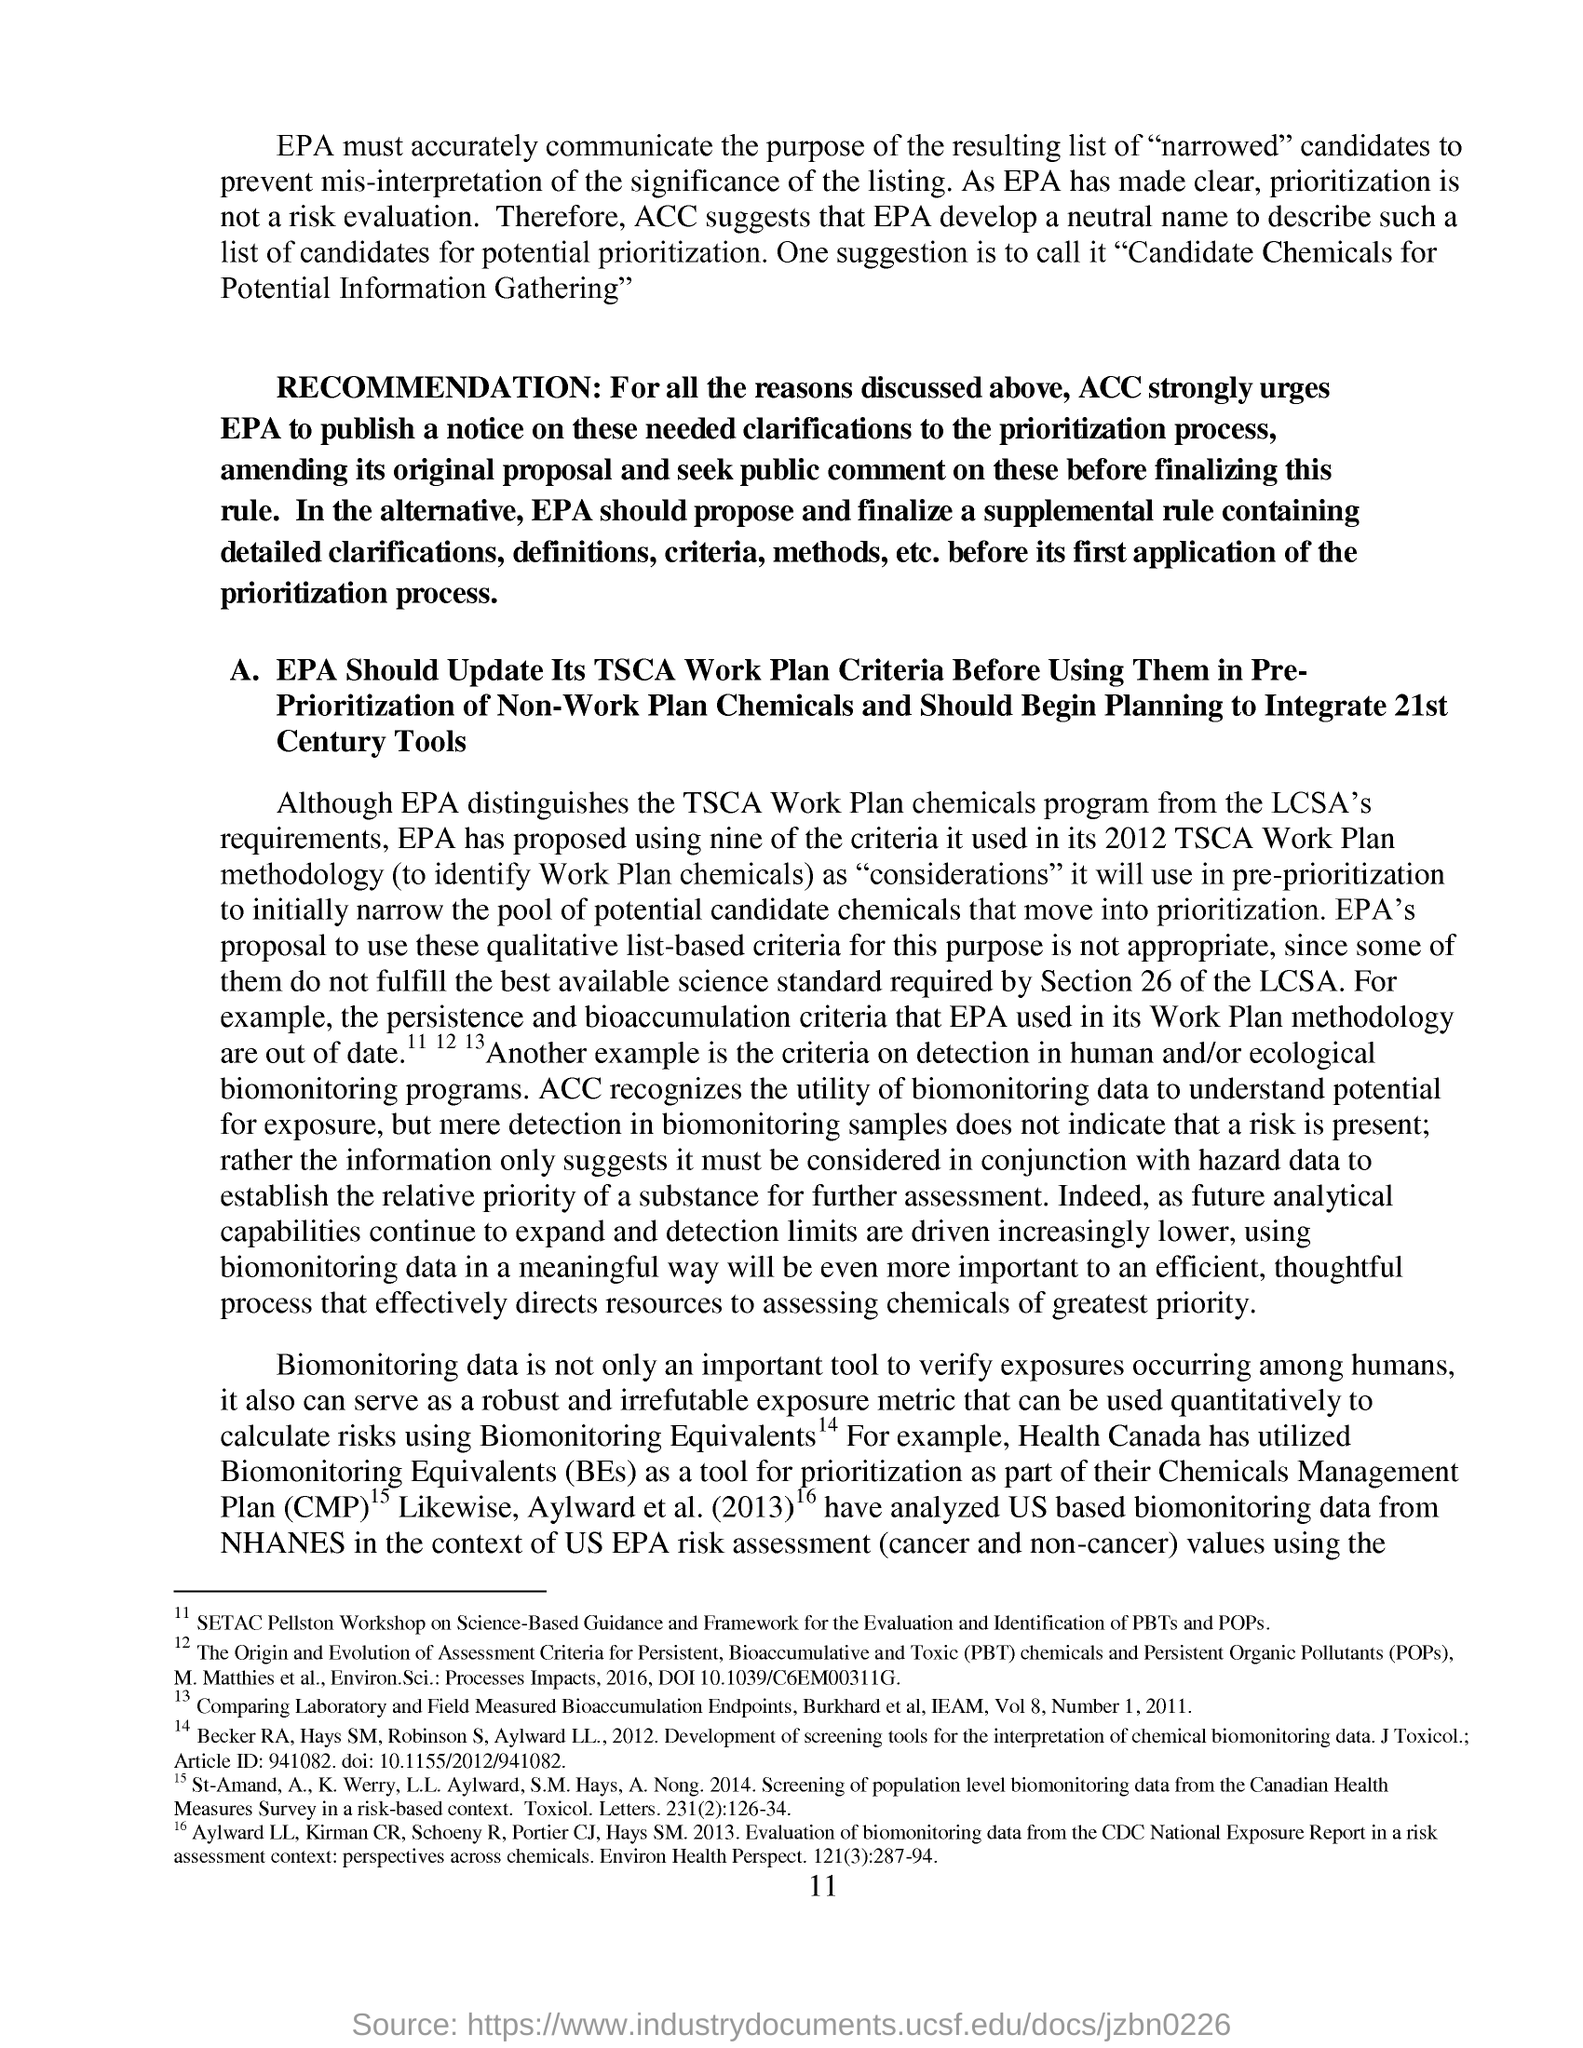What is the fullform of CMP?
Ensure brevity in your answer.  Chemicals Management Plan. What is the page no mentioned in this document?
Offer a terse response. 11. What is the abbreviation for Biomonitoring Equivalents?
Make the answer very short. BEs. 